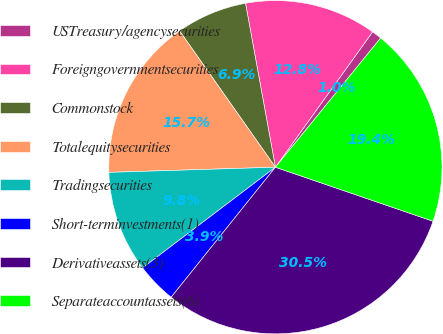<chart> <loc_0><loc_0><loc_500><loc_500><pie_chart><fcel>USTreasury/agencysecurities<fcel>Foreigngovernmentsecurities<fcel>Commonstock<fcel>Totalequitysecurities<fcel>Tradingsecurities<fcel>Short-terminvestments(1)<fcel>Derivativeassets(3)<fcel>Separateaccountassets(6)<nl><fcel>0.97%<fcel>12.78%<fcel>6.88%<fcel>15.74%<fcel>9.83%<fcel>3.92%<fcel>30.5%<fcel>19.37%<nl></chart> 